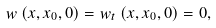<formula> <loc_0><loc_0><loc_500><loc_500>w \left ( x , x _ { 0 } , 0 \right ) = w _ { t } \left ( x , x _ { 0 } , 0 \right ) = 0 ,</formula> 